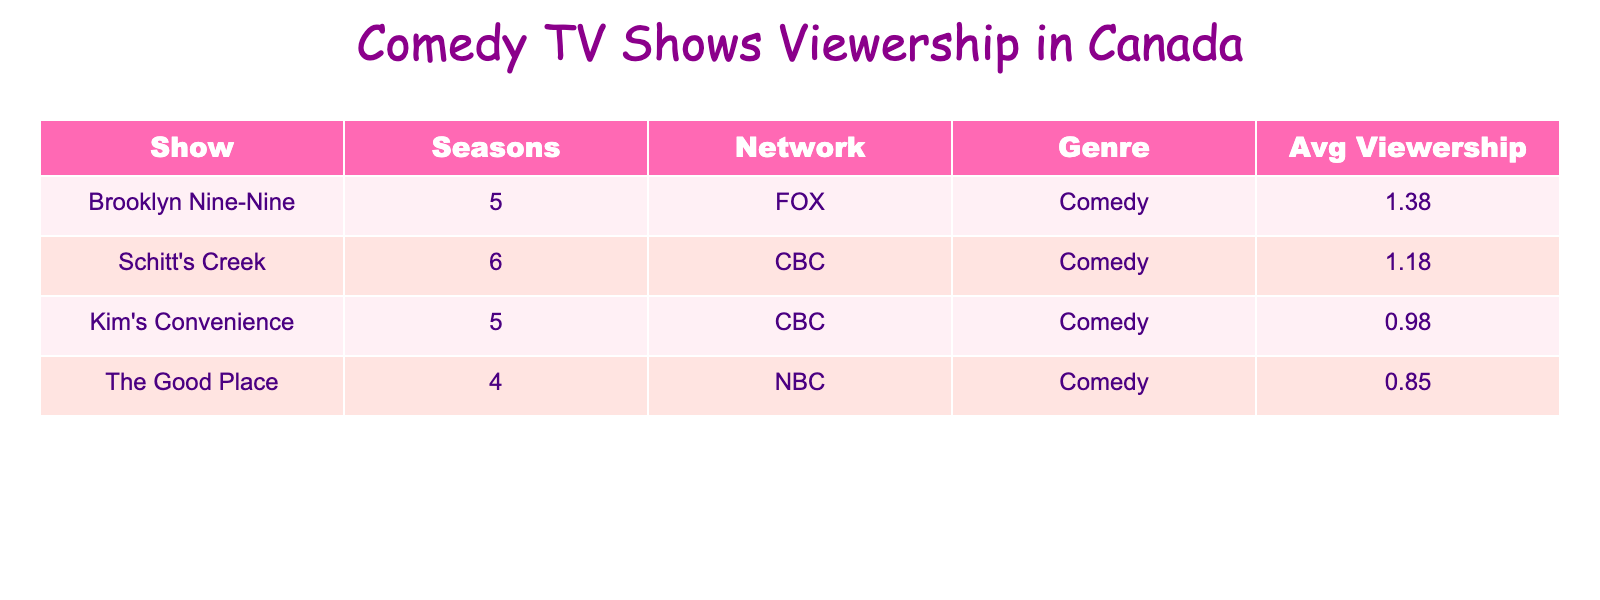What is the average viewership for Schitt's Creek? Looking at the table, the average viewership for Schitt's Creek is listed as 1.2 million viewers. This value is taken from the 'Avg Viewership' column corresponding to the show name.
Answer: 1.2 million Which show has the highest average viewership among these comedy shows? From the table, Brooklyn Nine-Nine has the highest average viewership at 1.5 million. This is determined by comparing the values in the 'Avg Viewership' column.
Answer: Brooklyn Nine-Nine Is there a season of Kim's Convenience with viewership lower than 1 million? Yes, according to the table, seasons 1 (0.6 million), 2 (0.8 million), and 4 (1.0 million) of Kim's Convenience all have viewership below 1 million.
Answer: Yes What is the total average viewership for Brooklyn Nine-Nine across all its seasons? To find the total average viewership for Brooklyn Nine-Nine, we sum the average viewership for each season: 1.3 + 1.5 + 1.6 + 1.4 + 1.1 = 6.9 million. The total viewership of 6.9 is then divided by 5, the number of seasons, to find the average, which comes out to 1.38 million.
Answer: 1.38 million What network broadcasts Kim's Convenience? Referring to the table, it shows that Kim's Convenience is aired on the CBC Network. This can be directly obtained from the 'Network' column.
Answer: CBC 